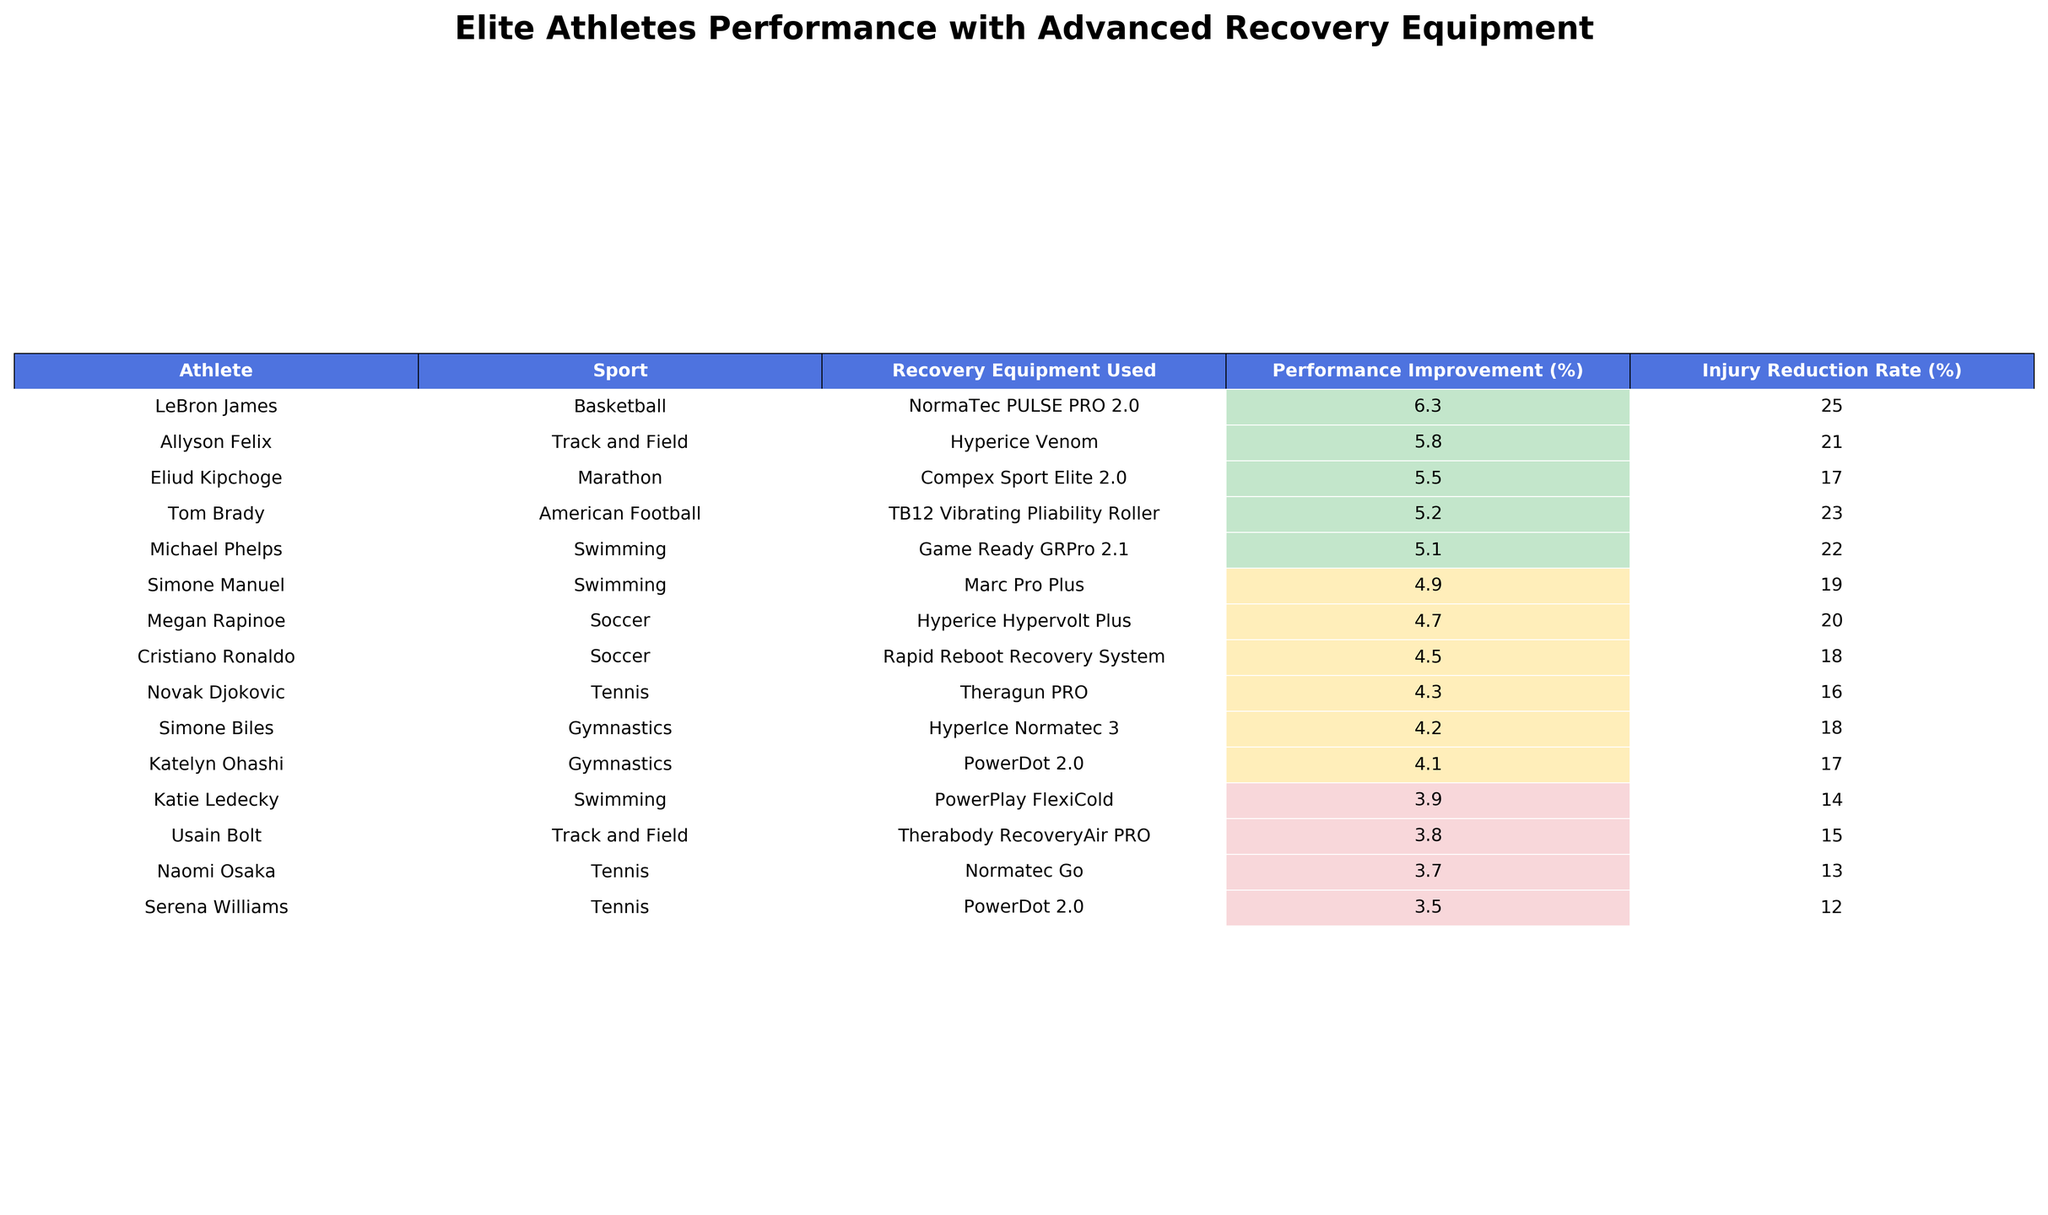What is the performance improvement percentage for Michael Phelps? According to the table, the performance improvement percentage for Michael Phelps is displayed in the column labeled "Performance Improvement (%)". Looking at the row for Michael Phelps, the value is 5.1%.
Answer: 5.1% Which athlete had the highest injury reduction rate? To determine which athlete had the highest injury reduction rate, I examine the "Injury Reduction Rate (%)" column and check all entries. The highest value in that column is 25%, which belongs to LeBron James.
Answer: LeBron James What is the average recovery time for the athletes listed in the table? First, I sum the recovery times from the "Recovery Time (hours)" column: (2.5 + 3 + 2 + 1.5 + 4 + 2 + 3.5 + 2.5 + 2 + 1.5 + 3 + 2 + 3.5 + 2) = 30. The total number of athletes is 14, so the average recovery time is 30/14 ≈ 2.14 hours.
Answer: 2.14 hours Did Naomi Osaka achieve a performance improvement greater than 4%? To assess if Naomi Osaka achieved a performance improvement greater than 4%, I check her entry in the "Performance Improvement (%)" column, which shows 3.7%. Since 3.7% is less than 4%, the answer is no.
Answer: No What percentage of athletes reported a satisfaction score of 9 or above? Looking at the "Athlete Satisfaction (1-10)" column, I count the athletes with scores of 9 or above, which are Simone Biles, LeBron James, Michael Phelps, Novak Djokovic, and Tom Brady – a total of 5 athletes. The total number of athletes is 14, so the percentage is (5/14) * 100 ≈ 35.7%.
Answer: 35.7% Which athlete used the NormaTec PULSE PRO 2.0 recovery equipment and what was their performance improvement? I search the "Recovery Equipment Used" column for the NormaTec PULSE PRO 2.0. The athlete associated with this equipment is LeBron James, and their performance improvement percentage is 6.3%.
Answer: LeBron James, 6.3% If we consider only the top three athletes in terms of performance improvement, what is the total injury reduction rate for these athletes? The top three athletes based on "Performance Improvement (%)" are LeBron James (25%), Michael Phelps (22%), and Allyson Felix (21%). Now I sum their injury reduction rates: 25 + 22 + 21 = 68%.
Answer: 68% Is there any athlete from the sport of Soccer who achieved a performance improvement above 4%? Checking the athletes listed under the sport of Soccer, I find Megan Rapinoe (4.7%) and Cristiano Ronaldo (4.5%). Since 4.5% does not exceed 4%, therefore the answer is yes.
Answer: Yes What is the satisfaction score for the athlete with the lowest performance improvement? I look for the lowest value in the "Performance Improvement (%)" column, which is 3.5% belonging to Serena Williams. Looking at the "Athlete Satisfaction (1-10)" column, her satisfaction score is 7.
Answer: 7 